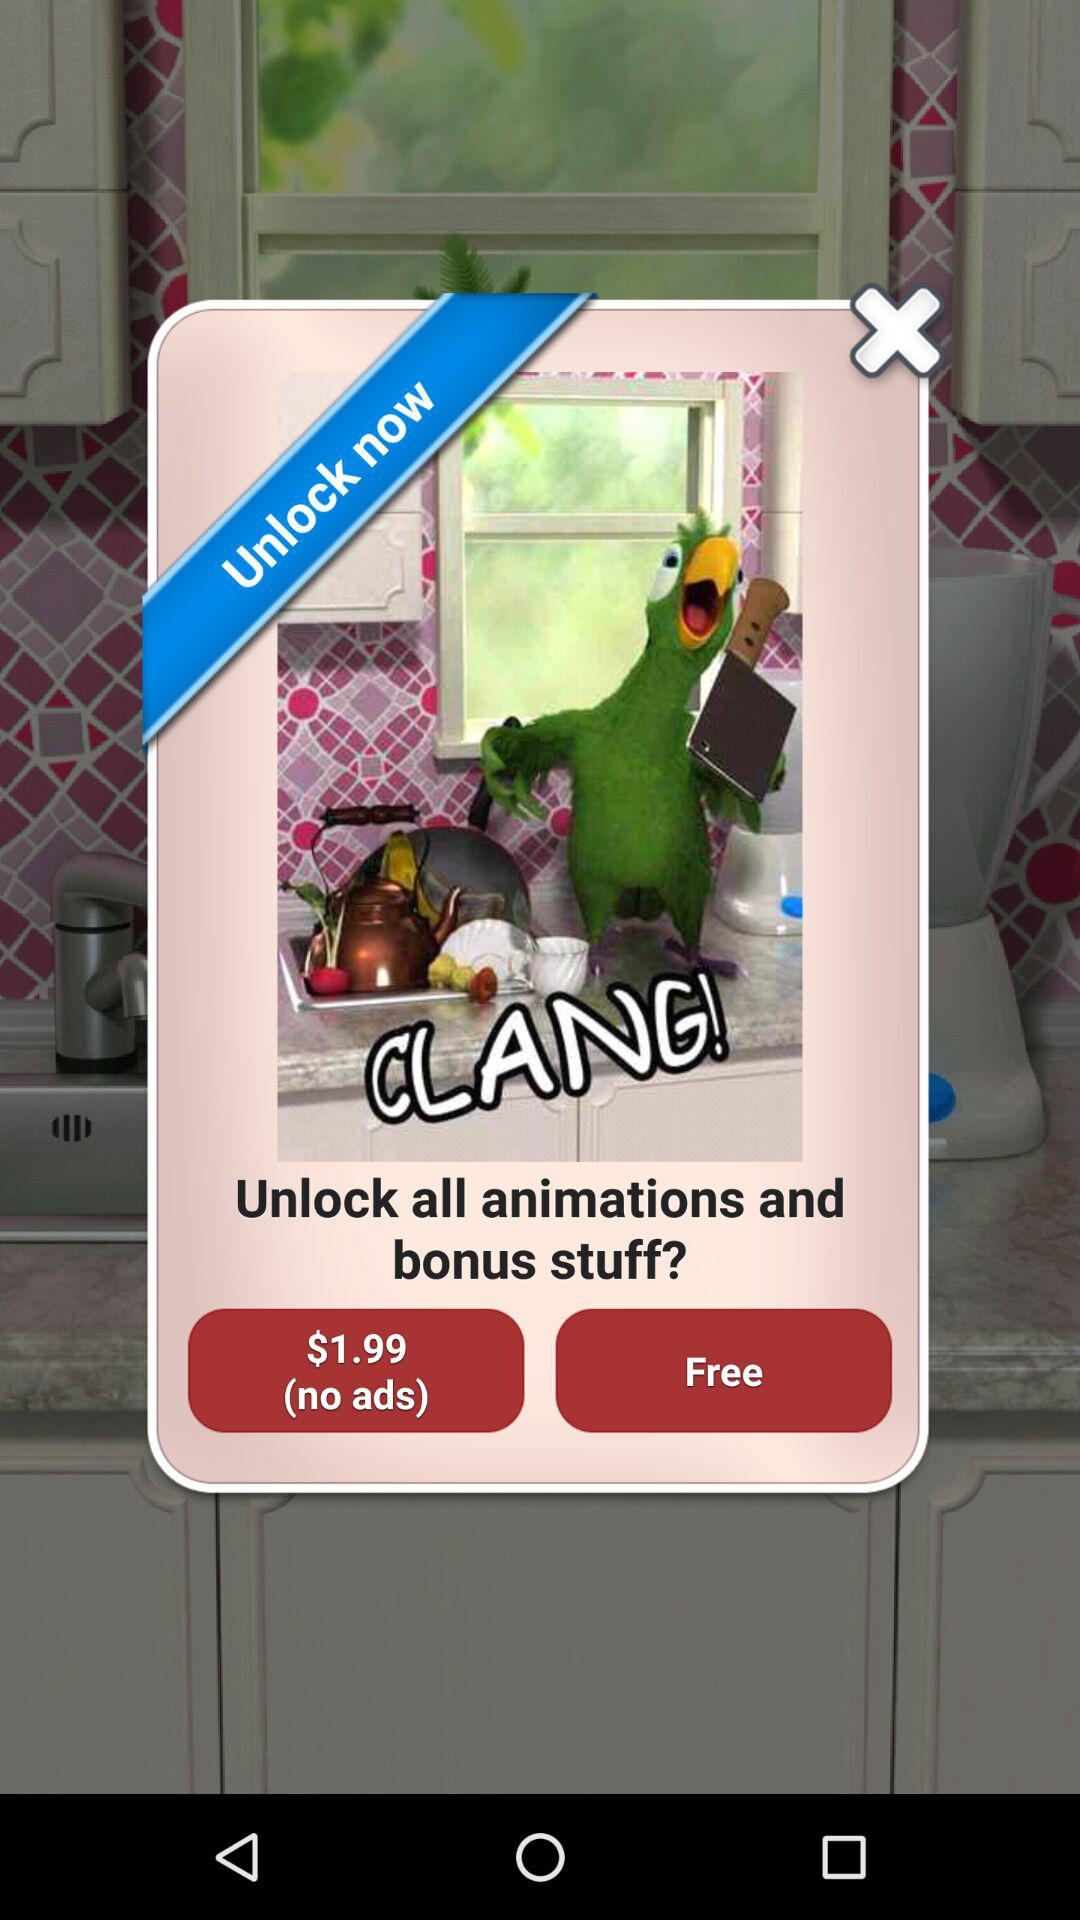How much more does the unlock all animations and bonus stuff option cost than the free option?
Answer the question using a single word or phrase. $1.99 